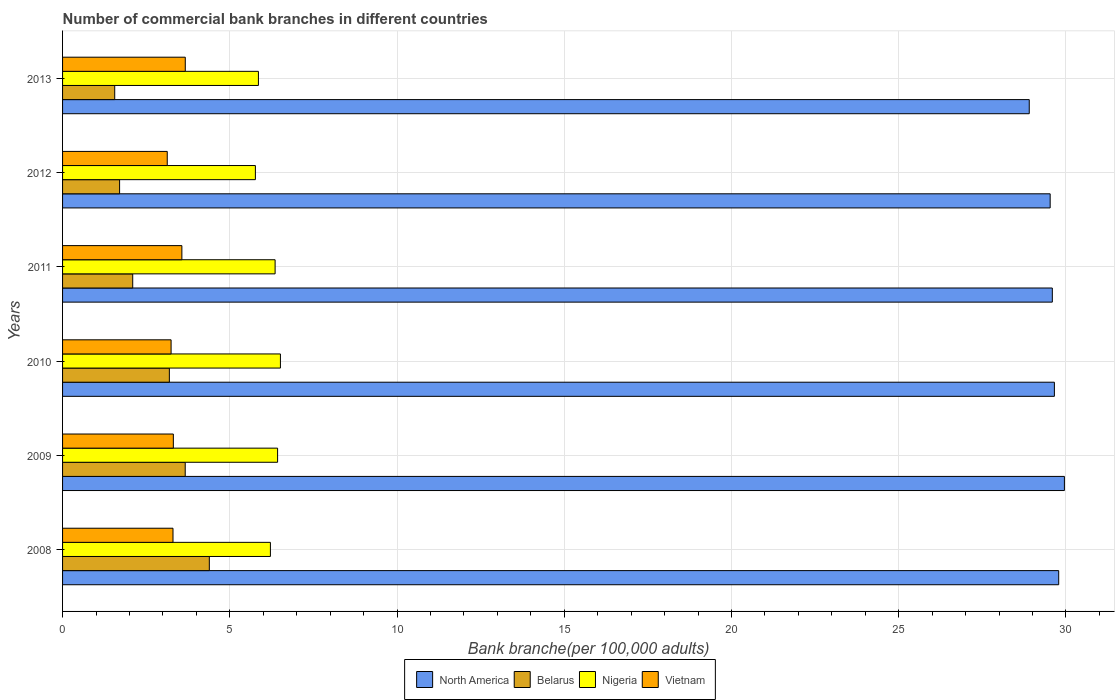In how many cases, is the number of bars for a given year not equal to the number of legend labels?
Keep it short and to the point. 0. What is the number of commercial bank branches in North America in 2009?
Your answer should be very brief. 29.95. Across all years, what is the maximum number of commercial bank branches in Vietnam?
Ensure brevity in your answer.  3.67. Across all years, what is the minimum number of commercial bank branches in Belarus?
Make the answer very short. 1.56. In which year was the number of commercial bank branches in Vietnam maximum?
Make the answer very short. 2013. In which year was the number of commercial bank branches in Belarus minimum?
Give a very brief answer. 2013. What is the total number of commercial bank branches in Belarus in the graph?
Offer a terse response. 16.61. What is the difference between the number of commercial bank branches in Nigeria in 2010 and that in 2011?
Your answer should be very brief. 0.16. What is the difference between the number of commercial bank branches in Belarus in 2010 and the number of commercial bank branches in Vietnam in 2009?
Provide a short and direct response. -0.12. What is the average number of commercial bank branches in North America per year?
Make the answer very short. 29.57. In the year 2011, what is the difference between the number of commercial bank branches in North America and number of commercial bank branches in Belarus?
Provide a short and direct response. 27.49. What is the ratio of the number of commercial bank branches in North America in 2011 to that in 2012?
Your response must be concise. 1. What is the difference between the highest and the second highest number of commercial bank branches in North America?
Your response must be concise. 0.17. What is the difference between the highest and the lowest number of commercial bank branches in Nigeria?
Make the answer very short. 0.75. Is the sum of the number of commercial bank branches in Vietnam in 2012 and 2013 greater than the maximum number of commercial bank branches in Belarus across all years?
Offer a terse response. Yes. Is it the case that in every year, the sum of the number of commercial bank branches in Nigeria and number of commercial bank branches in Vietnam is greater than the sum of number of commercial bank branches in North America and number of commercial bank branches in Belarus?
Offer a very short reply. Yes. What does the 3rd bar from the top in 2008 represents?
Ensure brevity in your answer.  Belarus. What does the 3rd bar from the bottom in 2011 represents?
Ensure brevity in your answer.  Nigeria. How many bars are there?
Provide a short and direct response. 24. What is the difference between two consecutive major ticks on the X-axis?
Make the answer very short. 5. Does the graph contain grids?
Offer a terse response. Yes. How many legend labels are there?
Ensure brevity in your answer.  4. How are the legend labels stacked?
Ensure brevity in your answer.  Horizontal. What is the title of the graph?
Keep it short and to the point. Number of commercial bank branches in different countries. What is the label or title of the X-axis?
Your answer should be very brief. Bank branche(per 100,0 adults). What is the Bank branche(per 100,000 adults) in North America in 2008?
Give a very brief answer. 29.78. What is the Bank branche(per 100,000 adults) of Belarus in 2008?
Give a very brief answer. 4.39. What is the Bank branche(per 100,000 adults) of Nigeria in 2008?
Give a very brief answer. 6.21. What is the Bank branche(per 100,000 adults) of Vietnam in 2008?
Give a very brief answer. 3.3. What is the Bank branche(per 100,000 adults) of North America in 2009?
Provide a short and direct response. 29.95. What is the Bank branche(per 100,000 adults) in Belarus in 2009?
Your answer should be very brief. 3.67. What is the Bank branche(per 100,000 adults) of Nigeria in 2009?
Your answer should be compact. 6.43. What is the Bank branche(per 100,000 adults) of Vietnam in 2009?
Your answer should be very brief. 3.31. What is the Bank branche(per 100,000 adults) in North America in 2010?
Your answer should be very brief. 29.65. What is the Bank branche(per 100,000 adults) in Belarus in 2010?
Provide a succinct answer. 3.19. What is the Bank branche(per 100,000 adults) of Nigeria in 2010?
Your answer should be compact. 6.51. What is the Bank branche(per 100,000 adults) in Vietnam in 2010?
Give a very brief answer. 3.24. What is the Bank branche(per 100,000 adults) in North America in 2011?
Your response must be concise. 29.59. What is the Bank branche(per 100,000 adults) of Belarus in 2011?
Offer a terse response. 2.1. What is the Bank branche(per 100,000 adults) in Nigeria in 2011?
Make the answer very short. 6.35. What is the Bank branche(per 100,000 adults) in Vietnam in 2011?
Offer a terse response. 3.57. What is the Bank branche(per 100,000 adults) of North America in 2012?
Keep it short and to the point. 29.53. What is the Bank branche(per 100,000 adults) in Belarus in 2012?
Make the answer very short. 1.71. What is the Bank branche(per 100,000 adults) in Nigeria in 2012?
Offer a very short reply. 5.76. What is the Bank branche(per 100,000 adults) in Vietnam in 2012?
Offer a very short reply. 3.13. What is the Bank branche(per 100,000 adults) in North America in 2013?
Your answer should be compact. 28.9. What is the Bank branche(per 100,000 adults) of Belarus in 2013?
Your answer should be compact. 1.56. What is the Bank branche(per 100,000 adults) of Nigeria in 2013?
Keep it short and to the point. 5.86. What is the Bank branche(per 100,000 adults) in Vietnam in 2013?
Provide a short and direct response. 3.67. Across all years, what is the maximum Bank branche(per 100,000 adults) of North America?
Your answer should be compact. 29.95. Across all years, what is the maximum Bank branche(per 100,000 adults) of Belarus?
Provide a succinct answer. 4.39. Across all years, what is the maximum Bank branche(per 100,000 adults) of Nigeria?
Your answer should be very brief. 6.51. Across all years, what is the maximum Bank branche(per 100,000 adults) in Vietnam?
Your response must be concise. 3.67. Across all years, what is the minimum Bank branche(per 100,000 adults) in North America?
Keep it short and to the point. 28.9. Across all years, what is the minimum Bank branche(per 100,000 adults) of Belarus?
Your response must be concise. 1.56. Across all years, what is the minimum Bank branche(per 100,000 adults) of Nigeria?
Ensure brevity in your answer.  5.76. Across all years, what is the minimum Bank branche(per 100,000 adults) of Vietnam?
Offer a terse response. 3.13. What is the total Bank branche(per 100,000 adults) of North America in the graph?
Your response must be concise. 177.41. What is the total Bank branche(per 100,000 adults) of Belarus in the graph?
Offer a terse response. 16.61. What is the total Bank branche(per 100,000 adults) in Nigeria in the graph?
Provide a succinct answer. 37.13. What is the total Bank branche(per 100,000 adults) of Vietnam in the graph?
Your answer should be compact. 20.22. What is the difference between the Bank branche(per 100,000 adults) of North America in 2008 and that in 2009?
Make the answer very short. -0.17. What is the difference between the Bank branche(per 100,000 adults) in Belarus in 2008 and that in 2009?
Keep it short and to the point. 0.72. What is the difference between the Bank branche(per 100,000 adults) in Nigeria in 2008 and that in 2009?
Provide a succinct answer. -0.21. What is the difference between the Bank branche(per 100,000 adults) in Vietnam in 2008 and that in 2009?
Provide a short and direct response. -0.01. What is the difference between the Bank branche(per 100,000 adults) of North America in 2008 and that in 2010?
Offer a very short reply. 0.13. What is the difference between the Bank branche(per 100,000 adults) in Belarus in 2008 and that in 2010?
Offer a very short reply. 1.19. What is the difference between the Bank branche(per 100,000 adults) in Nigeria in 2008 and that in 2010?
Your answer should be very brief. -0.3. What is the difference between the Bank branche(per 100,000 adults) of Vietnam in 2008 and that in 2010?
Keep it short and to the point. 0.06. What is the difference between the Bank branche(per 100,000 adults) of North America in 2008 and that in 2011?
Offer a terse response. 0.19. What is the difference between the Bank branche(per 100,000 adults) in Belarus in 2008 and that in 2011?
Your answer should be very brief. 2.29. What is the difference between the Bank branche(per 100,000 adults) of Nigeria in 2008 and that in 2011?
Your answer should be very brief. -0.14. What is the difference between the Bank branche(per 100,000 adults) of Vietnam in 2008 and that in 2011?
Provide a succinct answer. -0.27. What is the difference between the Bank branche(per 100,000 adults) of North America in 2008 and that in 2012?
Your response must be concise. 0.26. What is the difference between the Bank branche(per 100,000 adults) in Belarus in 2008 and that in 2012?
Ensure brevity in your answer.  2.68. What is the difference between the Bank branche(per 100,000 adults) in Nigeria in 2008 and that in 2012?
Your response must be concise. 0.45. What is the difference between the Bank branche(per 100,000 adults) in Vietnam in 2008 and that in 2012?
Make the answer very short. 0.17. What is the difference between the Bank branche(per 100,000 adults) in North America in 2008 and that in 2013?
Give a very brief answer. 0.88. What is the difference between the Bank branche(per 100,000 adults) of Belarus in 2008 and that in 2013?
Offer a very short reply. 2.83. What is the difference between the Bank branche(per 100,000 adults) in Nigeria in 2008 and that in 2013?
Your response must be concise. 0.36. What is the difference between the Bank branche(per 100,000 adults) of Vietnam in 2008 and that in 2013?
Your response must be concise. -0.37. What is the difference between the Bank branche(per 100,000 adults) of North America in 2009 and that in 2010?
Make the answer very short. 0.3. What is the difference between the Bank branche(per 100,000 adults) of Belarus in 2009 and that in 2010?
Your response must be concise. 0.47. What is the difference between the Bank branche(per 100,000 adults) of Nigeria in 2009 and that in 2010?
Provide a succinct answer. -0.08. What is the difference between the Bank branche(per 100,000 adults) of Vietnam in 2009 and that in 2010?
Make the answer very short. 0.07. What is the difference between the Bank branche(per 100,000 adults) of North America in 2009 and that in 2011?
Provide a succinct answer. 0.36. What is the difference between the Bank branche(per 100,000 adults) of Belarus in 2009 and that in 2011?
Your response must be concise. 1.57. What is the difference between the Bank branche(per 100,000 adults) of Nigeria in 2009 and that in 2011?
Ensure brevity in your answer.  0.07. What is the difference between the Bank branche(per 100,000 adults) of Vietnam in 2009 and that in 2011?
Keep it short and to the point. -0.26. What is the difference between the Bank branche(per 100,000 adults) in North America in 2009 and that in 2012?
Offer a very short reply. 0.43. What is the difference between the Bank branche(per 100,000 adults) of Belarus in 2009 and that in 2012?
Make the answer very short. 1.96. What is the difference between the Bank branche(per 100,000 adults) in Nigeria in 2009 and that in 2012?
Make the answer very short. 0.66. What is the difference between the Bank branche(per 100,000 adults) of Vietnam in 2009 and that in 2012?
Give a very brief answer. 0.18. What is the difference between the Bank branche(per 100,000 adults) in North America in 2009 and that in 2013?
Provide a succinct answer. 1.05. What is the difference between the Bank branche(per 100,000 adults) in Belarus in 2009 and that in 2013?
Give a very brief answer. 2.11. What is the difference between the Bank branche(per 100,000 adults) in Nigeria in 2009 and that in 2013?
Give a very brief answer. 0.57. What is the difference between the Bank branche(per 100,000 adults) in Vietnam in 2009 and that in 2013?
Offer a terse response. -0.36. What is the difference between the Bank branche(per 100,000 adults) of North America in 2010 and that in 2011?
Ensure brevity in your answer.  0.06. What is the difference between the Bank branche(per 100,000 adults) of Belarus in 2010 and that in 2011?
Offer a very short reply. 1.1. What is the difference between the Bank branche(per 100,000 adults) of Nigeria in 2010 and that in 2011?
Offer a very short reply. 0.16. What is the difference between the Bank branche(per 100,000 adults) in Vietnam in 2010 and that in 2011?
Ensure brevity in your answer.  -0.32. What is the difference between the Bank branche(per 100,000 adults) of North America in 2010 and that in 2012?
Make the answer very short. 0.13. What is the difference between the Bank branche(per 100,000 adults) of Belarus in 2010 and that in 2012?
Provide a succinct answer. 1.49. What is the difference between the Bank branche(per 100,000 adults) of Nigeria in 2010 and that in 2012?
Give a very brief answer. 0.75. What is the difference between the Bank branche(per 100,000 adults) in Vietnam in 2010 and that in 2012?
Offer a terse response. 0.11. What is the difference between the Bank branche(per 100,000 adults) of North America in 2010 and that in 2013?
Your answer should be very brief. 0.75. What is the difference between the Bank branche(per 100,000 adults) in Belarus in 2010 and that in 2013?
Provide a succinct answer. 1.63. What is the difference between the Bank branche(per 100,000 adults) of Nigeria in 2010 and that in 2013?
Provide a short and direct response. 0.66. What is the difference between the Bank branche(per 100,000 adults) in Vietnam in 2010 and that in 2013?
Your answer should be very brief. -0.42. What is the difference between the Bank branche(per 100,000 adults) in North America in 2011 and that in 2012?
Your answer should be very brief. 0.06. What is the difference between the Bank branche(per 100,000 adults) of Belarus in 2011 and that in 2012?
Your response must be concise. 0.39. What is the difference between the Bank branche(per 100,000 adults) of Nigeria in 2011 and that in 2012?
Provide a succinct answer. 0.59. What is the difference between the Bank branche(per 100,000 adults) of Vietnam in 2011 and that in 2012?
Your answer should be compact. 0.44. What is the difference between the Bank branche(per 100,000 adults) in North America in 2011 and that in 2013?
Offer a terse response. 0.69. What is the difference between the Bank branche(per 100,000 adults) of Belarus in 2011 and that in 2013?
Keep it short and to the point. 0.54. What is the difference between the Bank branche(per 100,000 adults) of Nigeria in 2011 and that in 2013?
Provide a succinct answer. 0.5. What is the difference between the Bank branche(per 100,000 adults) of Vietnam in 2011 and that in 2013?
Make the answer very short. -0.1. What is the difference between the Bank branche(per 100,000 adults) in North America in 2012 and that in 2013?
Provide a succinct answer. 0.63. What is the difference between the Bank branche(per 100,000 adults) in Belarus in 2012 and that in 2013?
Provide a short and direct response. 0.15. What is the difference between the Bank branche(per 100,000 adults) in Nigeria in 2012 and that in 2013?
Provide a short and direct response. -0.09. What is the difference between the Bank branche(per 100,000 adults) in Vietnam in 2012 and that in 2013?
Your answer should be very brief. -0.54. What is the difference between the Bank branche(per 100,000 adults) of North America in 2008 and the Bank branche(per 100,000 adults) of Belarus in 2009?
Your answer should be compact. 26.12. What is the difference between the Bank branche(per 100,000 adults) in North America in 2008 and the Bank branche(per 100,000 adults) in Nigeria in 2009?
Your answer should be compact. 23.35. What is the difference between the Bank branche(per 100,000 adults) of North America in 2008 and the Bank branche(per 100,000 adults) of Vietnam in 2009?
Give a very brief answer. 26.47. What is the difference between the Bank branche(per 100,000 adults) of Belarus in 2008 and the Bank branche(per 100,000 adults) of Nigeria in 2009?
Keep it short and to the point. -2.04. What is the difference between the Bank branche(per 100,000 adults) of Belarus in 2008 and the Bank branche(per 100,000 adults) of Vietnam in 2009?
Provide a short and direct response. 1.08. What is the difference between the Bank branche(per 100,000 adults) in Nigeria in 2008 and the Bank branche(per 100,000 adults) in Vietnam in 2009?
Provide a succinct answer. 2.9. What is the difference between the Bank branche(per 100,000 adults) of North America in 2008 and the Bank branche(per 100,000 adults) of Belarus in 2010?
Your answer should be compact. 26.59. What is the difference between the Bank branche(per 100,000 adults) of North America in 2008 and the Bank branche(per 100,000 adults) of Nigeria in 2010?
Provide a short and direct response. 23.27. What is the difference between the Bank branche(per 100,000 adults) of North America in 2008 and the Bank branche(per 100,000 adults) of Vietnam in 2010?
Offer a terse response. 26.54. What is the difference between the Bank branche(per 100,000 adults) of Belarus in 2008 and the Bank branche(per 100,000 adults) of Nigeria in 2010?
Give a very brief answer. -2.13. What is the difference between the Bank branche(per 100,000 adults) in Belarus in 2008 and the Bank branche(per 100,000 adults) in Vietnam in 2010?
Offer a terse response. 1.14. What is the difference between the Bank branche(per 100,000 adults) in Nigeria in 2008 and the Bank branche(per 100,000 adults) in Vietnam in 2010?
Your answer should be compact. 2.97. What is the difference between the Bank branche(per 100,000 adults) in North America in 2008 and the Bank branche(per 100,000 adults) in Belarus in 2011?
Give a very brief answer. 27.68. What is the difference between the Bank branche(per 100,000 adults) of North America in 2008 and the Bank branche(per 100,000 adults) of Nigeria in 2011?
Make the answer very short. 23.43. What is the difference between the Bank branche(per 100,000 adults) in North America in 2008 and the Bank branche(per 100,000 adults) in Vietnam in 2011?
Keep it short and to the point. 26.22. What is the difference between the Bank branche(per 100,000 adults) of Belarus in 2008 and the Bank branche(per 100,000 adults) of Nigeria in 2011?
Offer a terse response. -1.97. What is the difference between the Bank branche(per 100,000 adults) of Belarus in 2008 and the Bank branche(per 100,000 adults) of Vietnam in 2011?
Give a very brief answer. 0.82. What is the difference between the Bank branche(per 100,000 adults) in Nigeria in 2008 and the Bank branche(per 100,000 adults) in Vietnam in 2011?
Make the answer very short. 2.65. What is the difference between the Bank branche(per 100,000 adults) in North America in 2008 and the Bank branche(per 100,000 adults) in Belarus in 2012?
Provide a succinct answer. 28.08. What is the difference between the Bank branche(per 100,000 adults) in North America in 2008 and the Bank branche(per 100,000 adults) in Nigeria in 2012?
Your response must be concise. 24.02. What is the difference between the Bank branche(per 100,000 adults) in North America in 2008 and the Bank branche(per 100,000 adults) in Vietnam in 2012?
Your answer should be compact. 26.65. What is the difference between the Bank branche(per 100,000 adults) in Belarus in 2008 and the Bank branche(per 100,000 adults) in Nigeria in 2012?
Offer a terse response. -1.38. What is the difference between the Bank branche(per 100,000 adults) in Belarus in 2008 and the Bank branche(per 100,000 adults) in Vietnam in 2012?
Ensure brevity in your answer.  1.26. What is the difference between the Bank branche(per 100,000 adults) in Nigeria in 2008 and the Bank branche(per 100,000 adults) in Vietnam in 2012?
Ensure brevity in your answer.  3.08. What is the difference between the Bank branche(per 100,000 adults) in North America in 2008 and the Bank branche(per 100,000 adults) in Belarus in 2013?
Your answer should be compact. 28.22. What is the difference between the Bank branche(per 100,000 adults) of North America in 2008 and the Bank branche(per 100,000 adults) of Nigeria in 2013?
Provide a succinct answer. 23.93. What is the difference between the Bank branche(per 100,000 adults) of North America in 2008 and the Bank branche(per 100,000 adults) of Vietnam in 2013?
Offer a terse response. 26.11. What is the difference between the Bank branche(per 100,000 adults) in Belarus in 2008 and the Bank branche(per 100,000 adults) in Nigeria in 2013?
Keep it short and to the point. -1.47. What is the difference between the Bank branche(per 100,000 adults) in Belarus in 2008 and the Bank branche(per 100,000 adults) in Vietnam in 2013?
Your answer should be compact. 0.72. What is the difference between the Bank branche(per 100,000 adults) of Nigeria in 2008 and the Bank branche(per 100,000 adults) of Vietnam in 2013?
Provide a short and direct response. 2.55. What is the difference between the Bank branche(per 100,000 adults) in North America in 2009 and the Bank branche(per 100,000 adults) in Belarus in 2010?
Offer a very short reply. 26.76. What is the difference between the Bank branche(per 100,000 adults) in North America in 2009 and the Bank branche(per 100,000 adults) in Nigeria in 2010?
Your answer should be compact. 23.44. What is the difference between the Bank branche(per 100,000 adults) in North America in 2009 and the Bank branche(per 100,000 adults) in Vietnam in 2010?
Make the answer very short. 26.71. What is the difference between the Bank branche(per 100,000 adults) of Belarus in 2009 and the Bank branche(per 100,000 adults) of Nigeria in 2010?
Ensure brevity in your answer.  -2.85. What is the difference between the Bank branche(per 100,000 adults) of Belarus in 2009 and the Bank branche(per 100,000 adults) of Vietnam in 2010?
Ensure brevity in your answer.  0.42. What is the difference between the Bank branche(per 100,000 adults) in Nigeria in 2009 and the Bank branche(per 100,000 adults) in Vietnam in 2010?
Make the answer very short. 3.18. What is the difference between the Bank branche(per 100,000 adults) in North America in 2009 and the Bank branche(per 100,000 adults) in Belarus in 2011?
Ensure brevity in your answer.  27.86. What is the difference between the Bank branche(per 100,000 adults) in North America in 2009 and the Bank branche(per 100,000 adults) in Nigeria in 2011?
Your response must be concise. 23.6. What is the difference between the Bank branche(per 100,000 adults) of North America in 2009 and the Bank branche(per 100,000 adults) of Vietnam in 2011?
Offer a very short reply. 26.39. What is the difference between the Bank branche(per 100,000 adults) in Belarus in 2009 and the Bank branche(per 100,000 adults) in Nigeria in 2011?
Offer a very short reply. -2.69. What is the difference between the Bank branche(per 100,000 adults) in Belarus in 2009 and the Bank branche(per 100,000 adults) in Vietnam in 2011?
Your answer should be very brief. 0.1. What is the difference between the Bank branche(per 100,000 adults) of Nigeria in 2009 and the Bank branche(per 100,000 adults) of Vietnam in 2011?
Your answer should be compact. 2.86. What is the difference between the Bank branche(per 100,000 adults) in North America in 2009 and the Bank branche(per 100,000 adults) in Belarus in 2012?
Give a very brief answer. 28.25. What is the difference between the Bank branche(per 100,000 adults) in North America in 2009 and the Bank branche(per 100,000 adults) in Nigeria in 2012?
Your answer should be very brief. 24.19. What is the difference between the Bank branche(per 100,000 adults) in North America in 2009 and the Bank branche(per 100,000 adults) in Vietnam in 2012?
Offer a terse response. 26.82. What is the difference between the Bank branche(per 100,000 adults) of Belarus in 2009 and the Bank branche(per 100,000 adults) of Nigeria in 2012?
Provide a short and direct response. -2.1. What is the difference between the Bank branche(per 100,000 adults) in Belarus in 2009 and the Bank branche(per 100,000 adults) in Vietnam in 2012?
Make the answer very short. 0.54. What is the difference between the Bank branche(per 100,000 adults) of Nigeria in 2009 and the Bank branche(per 100,000 adults) of Vietnam in 2012?
Your response must be concise. 3.3. What is the difference between the Bank branche(per 100,000 adults) in North America in 2009 and the Bank branche(per 100,000 adults) in Belarus in 2013?
Provide a short and direct response. 28.39. What is the difference between the Bank branche(per 100,000 adults) of North America in 2009 and the Bank branche(per 100,000 adults) of Nigeria in 2013?
Make the answer very short. 24.1. What is the difference between the Bank branche(per 100,000 adults) in North America in 2009 and the Bank branche(per 100,000 adults) in Vietnam in 2013?
Give a very brief answer. 26.28. What is the difference between the Bank branche(per 100,000 adults) of Belarus in 2009 and the Bank branche(per 100,000 adults) of Nigeria in 2013?
Your answer should be compact. -2.19. What is the difference between the Bank branche(per 100,000 adults) in Belarus in 2009 and the Bank branche(per 100,000 adults) in Vietnam in 2013?
Ensure brevity in your answer.  -0. What is the difference between the Bank branche(per 100,000 adults) in Nigeria in 2009 and the Bank branche(per 100,000 adults) in Vietnam in 2013?
Provide a succinct answer. 2.76. What is the difference between the Bank branche(per 100,000 adults) in North America in 2010 and the Bank branche(per 100,000 adults) in Belarus in 2011?
Your response must be concise. 27.56. What is the difference between the Bank branche(per 100,000 adults) in North America in 2010 and the Bank branche(per 100,000 adults) in Nigeria in 2011?
Provide a short and direct response. 23.3. What is the difference between the Bank branche(per 100,000 adults) in North America in 2010 and the Bank branche(per 100,000 adults) in Vietnam in 2011?
Keep it short and to the point. 26.09. What is the difference between the Bank branche(per 100,000 adults) of Belarus in 2010 and the Bank branche(per 100,000 adults) of Nigeria in 2011?
Provide a succinct answer. -3.16. What is the difference between the Bank branche(per 100,000 adults) of Belarus in 2010 and the Bank branche(per 100,000 adults) of Vietnam in 2011?
Provide a succinct answer. -0.37. What is the difference between the Bank branche(per 100,000 adults) in Nigeria in 2010 and the Bank branche(per 100,000 adults) in Vietnam in 2011?
Keep it short and to the point. 2.95. What is the difference between the Bank branche(per 100,000 adults) of North America in 2010 and the Bank branche(per 100,000 adults) of Belarus in 2012?
Keep it short and to the point. 27.95. What is the difference between the Bank branche(per 100,000 adults) in North America in 2010 and the Bank branche(per 100,000 adults) in Nigeria in 2012?
Your answer should be compact. 23.89. What is the difference between the Bank branche(per 100,000 adults) in North America in 2010 and the Bank branche(per 100,000 adults) in Vietnam in 2012?
Ensure brevity in your answer.  26.52. What is the difference between the Bank branche(per 100,000 adults) in Belarus in 2010 and the Bank branche(per 100,000 adults) in Nigeria in 2012?
Provide a succinct answer. -2.57. What is the difference between the Bank branche(per 100,000 adults) in Belarus in 2010 and the Bank branche(per 100,000 adults) in Vietnam in 2012?
Offer a very short reply. 0.06. What is the difference between the Bank branche(per 100,000 adults) of Nigeria in 2010 and the Bank branche(per 100,000 adults) of Vietnam in 2012?
Ensure brevity in your answer.  3.38. What is the difference between the Bank branche(per 100,000 adults) of North America in 2010 and the Bank branche(per 100,000 adults) of Belarus in 2013?
Offer a very short reply. 28.09. What is the difference between the Bank branche(per 100,000 adults) of North America in 2010 and the Bank branche(per 100,000 adults) of Nigeria in 2013?
Make the answer very short. 23.8. What is the difference between the Bank branche(per 100,000 adults) of North America in 2010 and the Bank branche(per 100,000 adults) of Vietnam in 2013?
Provide a succinct answer. 25.98. What is the difference between the Bank branche(per 100,000 adults) in Belarus in 2010 and the Bank branche(per 100,000 adults) in Nigeria in 2013?
Provide a succinct answer. -2.66. What is the difference between the Bank branche(per 100,000 adults) in Belarus in 2010 and the Bank branche(per 100,000 adults) in Vietnam in 2013?
Make the answer very short. -0.48. What is the difference between the Bank branche(per 100,000 adults) of Nigeria in 2010 and the Bank branche(per 100,000 adults) of Vietnam in 2013?
Ensure brevity in your answer.  2.84. What is the difference between the Bank branche(per 100,000 adults) in North America in 2011 and the Bank branche(per 100,000 adults) in Belarus in 2012?
Provide a succinct answer. 27.89. What is the difference between the Bank branche(per 100,000 adults) in North America in 2011 and the Bank branche(per 100,000 adults) in Nigeria in 2012?
Make the answer very short. 23.83. What is the difference between the Bank branche(per 100,000 adults) of North America in 2011 and the Bank branche(per 100,000 adults) of Vietnam in 2012?
Provide a short and direct response. 26.46. What is the difference between the Bank branche(per 100,000 adults) in Belarus in 2011 and the Bank branche(per 100,000 adults) in Nigeria in 2012?
Provide a short and direct response. -3.67. What is the difference between the Bank branche(per 100,000 adults) of Belarus in 2011 and the Bank branche(per 100,000 adults) of Vietnam in 2012?
Offer a terse response. -1.03. What is the difference between the Bank branche(per 100,000 adults) of Nigeria in 2011 and the Bank branche(per 100,000 adults) of Vietnam in 2012?
Offer a terse response. 3.22. What is the difference between the Bank branche(per 100,000 adults) of North America in 2011 and the Bank branche(per 100,000 adults) of Belarus in 2013?
Make the answer very short. 28.03. What is the difference between the Bank branche(per 100,000 adults) in North America in 2011 and the Bank branche(per 100,000 adults) in Nigeria in 2013?
Provide a succinct answer. 23.74. What is the difference between the Bank branche(per 100,000 adults) in North America in 2011 and the Bank branche(per 100,000 adults) in Vietnam in 2013?
Your response must be concise. 25.92. What is the difference between the Bank branche(per 100,000 adults) of Belarus in 2011 and the Bank branche(per 100,000 adults) of Nigeria in 2013?
Give a very brief answer. -3.76. What is the difference between the Bank branche(per 100,000 adults) of Belarus in 2011 and the Bank branche(per 100,000 adults) of Vietnam in 2013?
Offer a very short reply. -1.57. What is the difference between the Bank branche(per 100,000 adults) in Nigeria in 2011 and the Bank branche(per 100,000 adults) in Vietnam in 2013?
Provide a succinct answer. 2.69. What is the difference between the Bank branche(per 100,000 adults) of North America in 2012 and the Bank branche(per 100,000 adults) of Belarus in 2013?
Provide a short and direct response. 27.97. What is the difference between the Bank branche(per 100,000 adults) in North America in 2012 and the Bank branche(per 100,000 adults) in Nigeria in 2013?
Offer a very short reply. 23.67. What is the difference between the Bank branche(per 100,000 adults) of North America in 2012 and the Bank branche(per 100,000 adults) of Vietnam in 2013?
Make the answer very short. 25.86. What is the difference between the Bank branche(per 100,000 adults) in Belarus in 2012 and the Bank branche(per 100,000 adults) in Nigeria in 2013?
Your answer should be very brief. -4.15. What is the difference between the Bank branche(per 100,000 adults) of Belarus in 2012 and the Bank branche(per 100,000 adults) of Vietnam in 2013?
Ensure brevity in your answer.  -1.96. What is the difference between the Bank branche(per 100,000 adults) in Nigeria in 2012 and the Bank branche(per 100,000 adults) in Vietnam in 2013?
Provide a succinct answer. 2.1. What is the average Bank branche(per 100,000 adults) in North America per year?
Provide a succinct answer. 29.57. What is the average Bank branche(per 100,000 adults) in Belarus per year?
Offer a very short reply. 2.77. What is the average Bank branche(per 100,000 adults) of Nigeria per year?
Keep it short and to the point. 6.19. What is the average Bank branche(per 100,000 adults) of Vietnam per year?
Keep it short and to the point. 3.37. In the year 2008, what is the difference between the Bank branche(per 100,000 adults) in North America and Bank branche(per 100,000 adults) in Belarus?
Your answer should be compact. 25.39. In the year 2008, what is the difference between the Bank branche(per 100,000 adults) of North America and Bank branche(per 100,000 adults) of Nigeria?
Your answer should be compact. 23.57. In the year 2008, what is the difference between the Bank branche(per 100,000 adults) in North America and Bank branche(per 100,000 adults) in Vietnam?
Your answer should be compact. 26.48. In the year 2008, what is the difference between the Bank branche(per 100,000 adults) in Belarus and Bank branche(per 100,000 adults) in Nigeria?
Make the answer very short. -1.83. In the year 2008, what is the difference between the Bank branche(per 100,000 adults) in Belarus and Bank branche(per 100,000 adults) in Vietnam?
Ensure brevity in your answer.  1.09. In the year 2008, what is the difference between the Bank branche(per 100,000 adults) in Nigeria and Bank branche(per 100,000 adults) in Vietnam?
Make the answer very short. 2.91. In the year 2009, what is the difference between the Bank branche(per 100,000 adults) in North America and Bank branche(per 100,000 adults) in Belarus?
Offer a terse response. 26.29. In the year 2009, what is the difference between the Bank branche(per 100,000 adults) of North America and Bank branche(per 100,000 adults) of Nigeria?
Provide a succinct answer. 23.52. In the year 2009, what is the difference between the Bank branche(per 100,000 adults) in North America and Bank branche(per 100,000 adults) in Vietnam?
Make the answer very short. 26.64. In the year 2009, what is the difference between the Bank branche(per 100,000 adults) in Belarus and Bank branche(per 100,000 adults) in Nigeria?
Ensure brevity in your answer.  -2.76. In the year 2009, what is the difference between the Bank branche(per 100,000 adults) in Belarus and Bank branche(per 100,000 adults) in Vietnam?
Your answer should be compact. 0.36. In the year 2009, what is the difference between the Bank branche(per 100,000 adults) of Nigeria and Bank branche(per 100,000 adults) of Vietnam?
Your answer should be very brief. 3.12. In the year 2010, what is the difference between the Bank branche(per 100,000 adults) of North America and Bank branche(per 100,000 adults) of Belarus?
Ensure brevity in your answer.  26.46. In the year 2010, what is the difference between the Bank branche(per 100,000 adults) in North America and Bank branche(per 100,000 adults) in Nigeria?
Your answer should be very brief. 23.14. In the year 2010, what is the difference between the Bank branche(per 100,000 adults) of North America and Bank branche(per 100,000 adults) of Vietnam?
Give a very brief answer. 26.41. In the year 2010, what is the difference between the Bank branche(per 100,000 adults) in Belarus and Bank branche(per 100,000 adults) in Nigeria?
Make the answer very short. -3.32. In the year 2010, what is the difference between the Bank branche(per 100,000 adults) in Belarus and Bank branche(per 100,000 adults) in Vietnam?
Offer a very short reply. -0.05. In the year 2010, what is the difference between the Bank branche(per 100,000 adults) of Nigeria and Bank branche(per 100,000 adults) of Vietnam?
Offer a very short reply. 3.27. In the year 2011, what is the difference between the Bank branche(per 100,000 adults) in North America and Bank branche(per 100,000 adults) in Belarus?
Your answer should be very brief. 27.49. In the year 2011, what is the difference between the Bank branche(per 100,000 adults) in North America and Bank branche(per 100,000 adults) in Nigeria?
Keep it short and to the point. 23.24. In the year 2011, what is the difference between the Bank branche(per 100,000 adults) of North America and Bank branche(per 100,000 adults) of Vietnam?
Ensure brevity in your answer.  26.02. In the year 2011, what is the difference between the Bank branche(per 100,000 adults) in Belarus and Bank branche(per 100,000 adults) in Nigeria?
Offer a very short reply. -4.26. In the year 2011, what is the difference between the Bank branche(per 100,000 adults) of Belarus and Bank branche(per 100,000 adults) of Vietnam?
Your response must be concise. -1.47. In the year 2011, what is the difference between the Bank branche(per 100,000 adults) of Nigeria and Bank branche(per 100,000 adults) of Vietnam?
Offer a very short reply. 2.79. In the year 2012, what is the difference between the Bank branche(per 100,000 adults) in North America and Bank branche(per 100,000 adults) in Belarus?
Offer a very short reply. 27.82. In the year 2012, what is the difference between the Bank branche(per 100,000 adults) of North America and Bank branche(per 100,000 adults) of Nigeria?
Offer a very short reply. 23.76. In the year 2012, what is the difference between the Bank branche(per 100,000 adults) of North America and Bank branche(per 100,000 adults) of Vietnam?
Ensure brevity in your answer.  26.4. In the year 2012, what is the difference between the Bank branche(per 100,000 adults) in Belarus and Bank branche(per 100,000 adults) in Nigeria?
Keep it short and to the point. -4.06. In the year 2012, what is the difference between the Bank branche(per 100,000 adults) in Belarus and Bank branche(per 100,000 adults) in Vietnam?
Your answer should be compact. -1.42. In the year 2012, what is the difference between the Bank branche(per 100,000 adults) in Nigeria and Bank branche(per 100,000 adults) in Vietnam?
Provide a short and direct response. 2.64. In the year 2013, what is the difference between the Bank branche(per 100,000 adults) of North America and Bank branche(per 100,000 adults) of Belarus?
Your answer should be compact. 27.34. In the year 2013, what is the difference between the Bank branche(per 100,000 adults) of North America and Bank branche(per 100,000 adults) of Nigeria?
Your answer should be very brief. 23.05. In the year 2013, what is the difference between the Bank branche(per 100,000 adults) of North America and Bank branche(per 100,000 adults) of Vietnam?
Your answer should be compact. 25.23. In the year 2013, what is the difference between the Bank branche(per 100,000 adults) of Belarus and Bank branche(per 100,000 adults) of Nigeria?
Offer a terse response. -4.3. In the year 2013, what is the difference between the Bank branche(per 100,000 adults) in Belarus and Bank branche(per 100,000 adults) in Vietnam?
Offer a terse response. -2.11. In the year 2013, what is the difference between the Bank branche(per 100,000 adults) in Nigeria and Bank branche(per 100,000 adults) in Vietnam?
Keep it short and to the point. 2.19. What is the ratio of the Bank branche(per 100,000 adults) in Belarus in 2008 to that in 2009?
Provide a short and direct response. 1.2. What is the ratio of the Bank branche(per 100,000 adults) of Nigeria in 2008 to that in 2009?
Keep it short and to the point. 0.97. What is the ratio of the Bank branche(per 100,000 adults) in Vietnam in 2008 to that in 2009?
Keep it short and to the point. 1. What is the ratio of the Bank branche(per 100,000 adults) of Belarus in 2008 to that in 2010?
Give a very brief answer. 1.37. What is the ratio of the Bank branche(per 100,000 adults) in Nigeria in 2008 to that in 2010?
Your answer should be very brief. 0.95. What is the ratio of the Bank branche(per 100,000 adults) of Vietnam in 2008 to that in 2010?
Your answer should be very brief. 1.02. What is the ratio of the Bank branche(per 100,000 adults) of Belarus in 2008 to that in 2011?
Give a very brief answer. 2.09. What is the ratio of the Bank branche(per 100,000 adults) of Nigeria in 2008 to that in 2011?
Your answer should be compact. 0.98. What is the ratio of the Bank branche(per 100,000 adults) of Vietnam in 2008 to that in 2011?
Your answer should be compact. 0.93. What is the ratio of the Bank branche(per 100,000 adults) in North America in 2008 to that in 2012?
Your answer should be very brief. 1.01. What is the ratio of the Bank branche(per 100,000 adults) of Belarus in 2008 to that in 2012?
Your answer should be compact. 2.57. What is the ratio of the Bank branche(per 100,000 adults) in Nigeria in 2008 to that in 2012?
Offer a very short reply. 1.08. What is the ratio of the Bank branche(per 100,000 adults) of Vietnam in 2008 to that in 2012?
Offer a terse response. 1.05. What is the ratio of the Bank branche(per 100,000 adults) of North America in 2008 to that in 2013?
Offer a terse response. 1.03. What is the ratio of the Bank branche(per 100,000 adults) of Belarus in 2008 to that in 2013?
Offer a very short reply. 2.81. What is the ratio of the Bank branche(per 100,000 adults) of Nigeria in 2008 to that in 2013?
Keep it short and to the point. 1.06. What is the ratio of the Bank branche(per 100,000 adults) in Vietnam in 2008 to that in 2013?
Your answer should be very brief. 0.9. What is the ratio of the Bank branche(per 100,000 adults) in Belarus in 2009 to that in 2010?
Give a very brief answer. 1.15. What is the ratio of the Bank branche(per 100,000 adults) in Vietnam in 2009 to that in 2010?
Ensure brevity in your answer.  1.02. What is the ratio of the Bank branche(per 100,000 adults) of North America in 2009 to that in 2011?
Make the answer very short. 1.01. What is the ratio of the Bank branche(per 100,000 adults) in Belarus in 2009 to that in 2011?
Your answer should be very brief. 1.75. What is the ratio of the Bank branche(per 100,000 adults) in Nigeria in 2009 to that in 2011?
Your response must be concise. 1.01. What is the ratio of the Bank branche(per 100,000 adults) of Vietnam in 2009 to that in 2011?
Your answer should be compact. 0.93. What is the ratio of the Bank branche(per 100,000 adults) of North America in 2009 to that in 2012?
Offer a very short reply. 1.01. What is the ratio of the Bank branche(per 100,000 adults) in Belarus in 2009 to that in 2012?
Provide a succinct answer. 2.15. What is the ratio of the Bank branche(per 100,000 adults) in Nigeria in 2009 to that in 2012?
Offer a terse response. 1.12. What is the ratio of the Bank branche(per 100,000 adults) of Vietnam in 2009 to that in 2012?
Your answer should be very brief. 1.06. What is the ratio of the Bank branche(per 100,000 adults) in North America in 2009 to that in 2013?
Your response must be concise. 1.04. What is the ratio of the Bank branche(per 100,000 adults) in Belarus in 2009 to that in 2013?
Provide a short and direct response. 2.35. What is the ratio of the Bank branche(per 100,000 adults) of Nigeria in 2009 to that in 2013?
Provide a short and direct response. 1.1. What is the ratio of the Bank branche(per 100,000 adults) of Vietnam in 2009 to that in 2013?
Make the answer very short. 0.9. What is the ratio of the Bank branche(per 100,000 adults) in Belarus in 2010 to that in 2011?
Offer a very short reply. 1.52. What is the ratio of the Bank branche(per 100,000 adults) of Nigeria in 2010 to that in 2011?
Offer a terse response. 1.02. What is the ratio of the Bank branche(per 100,000 adults) in Vietnam in 2010 to that in 2011?
Your answer should be compact. 0.91. What is the ratio of the Bank branche(per 100,000 adults) of North America in 2010 to that in 2012?
Give a very brief answer. 1. What is the ratio of the Bank branche(per 100,000 adults) in Belarus in 2010 to that in 2012?
Your answer should be very brief. 1.87. What is the ratio of the Bank branche(per 100,000 adults) in Nigeria in 2010 to that in 2012?
Ensure brevity in your answer.  1.13. What is the ratio of the Bank branche(per 100,000 adults) in Vietnam in 2010 to that in 2012?
Provide a short and direct response. 1.04. What is the ratio of the Bank branche(per 100,000 adults) of Belarus in 2010 to that in 2013?
Provide a succinct answer. 2.05. What is the ratio of the Bank branche(per 100,000 adults) of Nigeria in 2010 to that in 2013?
Offer a terse response. 1.11. What is the ratio of the Bank branche(per 100,000 adults) of Vietnam in 2010 to that in 2013?
Provide a succinct answer. 0.88. What is the ratio of the Bank branche(per 100,000 adults) in Belarus in 2011 to that in 2012?
Make the answer very short. 1.23. What is the ratio of the Bank branche(per 100,000 adults) of Nigeria in 2011 to that in 2012?
Make the answer very short. 1.1. What is the ratio of the Bank branche(per 100,000 adults) of Vietnam in 2011 to that in 2012?
Make the answer very short. 1.14. What is the ratio of the Bank branche(per 100,000 adults) of North America in 2011 to that in 2013?
Provide a short and direct response. 1.02. What is the ratio of the Bank branche(per 100,000 adults) of Belarus in 2011 to that in 2013?
Give a very brief answer. 1.35. What is the ratio of the Bank branche(per 100,000 adults) of Nigeria in 2011 to that in 2013?
Offer a very short reply. 1.09. What is the ratio of the Bank branche(per 100,000 adults) in Vietnam in 2011 to that in 2013?
Your answer should be very brief. 0.97. What is the ratio of the Bank branche(per 100,000 adults) of North America in 2012 to that in 2013?
Offer a very short reply. 1.02. What is the ratio of the Bank branche(per 100,000 adults) of Belarus in 2012 to that in 2013?
Make the answer very short. 1.09. What is the ratio of the Bank branche(per 100,000 adults) in Nigeria in 2012 to that in 2013?
Your response must be concise. 0.98. What is the ratio of the Bank branche(per 100,000 adults) of Vietnam in 2012 to that in 2013?
Your answer should be very brief. 0.85. What is the difference between the highest and the second highest Bank branche(per 100,000 adults) of North America?
Make the answer very short. 0.17. What is the difference between the highest and the second highest Bank branche(per 100,000 adults) in Belarus?
Provide a short and direct response. 0.72. What is the difference between the highest and the second highest Bank branche(per 100,000 adults) in Nigeria?
Your answer should be compact. 0.08. What is the difference between the highest and the second highest Bank branche(per 100,000 adults) in Vietnam?
Your answer should be very brief. 0.1. What is the difference between the highest and the lowest Bank branche(per 100,000 adults) of North America?
Ensure brevity in your answer.  1.05. What is the difference between the highest and the lowest Bank branche(per 100,000 adults) in Belarus?
Provide a short and direct response. 2.83. What is the difference between the highest and the lowest Bank branche(per 100,000 adults) in Nigeria?
Your response must be concise. 0.75. What is the difference between the highest and the lowest Bank branche(per 100,000 adults) of Vietnam?
Keep it short and to the point. 0.54. 